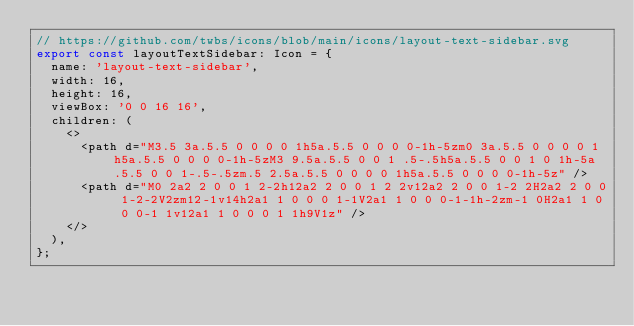Convert code to text. <code><loc_0><loc_0><loc_500><loc_500><_TypeScript_>// https://github.com/twbs/icons/blob/main/icons/layout-text-sidebar.svg
export const layoutTextSidebar: Icon = {
  name: 'layout-text-sidebar',
  width: 16,
  height: 16,
  viewBox: '0 0 16 16',
  children: (
    <>
      <path d="M3.5 3a.5.5 0 0 0 0 1h5a.5.5 0 0 0 0-1h-5zm0 3a.5.5 0 0 0 0 1h5a.5.5 0 0 0 0-1h-5zM3 9.5a.5.5 0 0 1 .5-.5h5a.5.5 0 0 1 0 1h-5a.5.5 0 0 1-.5-.5zm.5 2.5a.5.5 0 0 0 0 1h5a.5.5 0 0 0 0-1h-5z" />
      <path d="M0 2a2 2 0 0 1 2-2h12a2 2 0 0 1 2 2v12a2 2 0 0 1-2 2H2a2 2 0 0 1-2-2V2zm12-1v14h2a1 1 0 0 0 1-1V2a1 1 0 0 0-1-1h-2zm-1 0H2a1 1 0 0 0-1 1v12a1 1 0 0 0 1 1h9V1z" />
    </>
  ),
};
</code> 